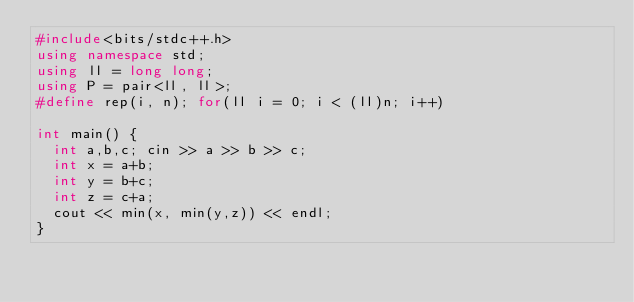Convert code to text. <code><loc_0><loc_0><loc_500><loc_500><_C++_>#include<bits/stdc++.h>
using namespace std;
using ll = long long;
using P = pair<ll, ll>;
#define rep(i, n); for(ll i = 0; i < (ll)n; i++)

int main() {
  int a,b,c; cin >> a >> b >> c;
  int x = a+b;
  int y = b+c;
  int z = c+a;
  cout << min(x, min(y,z)) << endl;
}</code> 